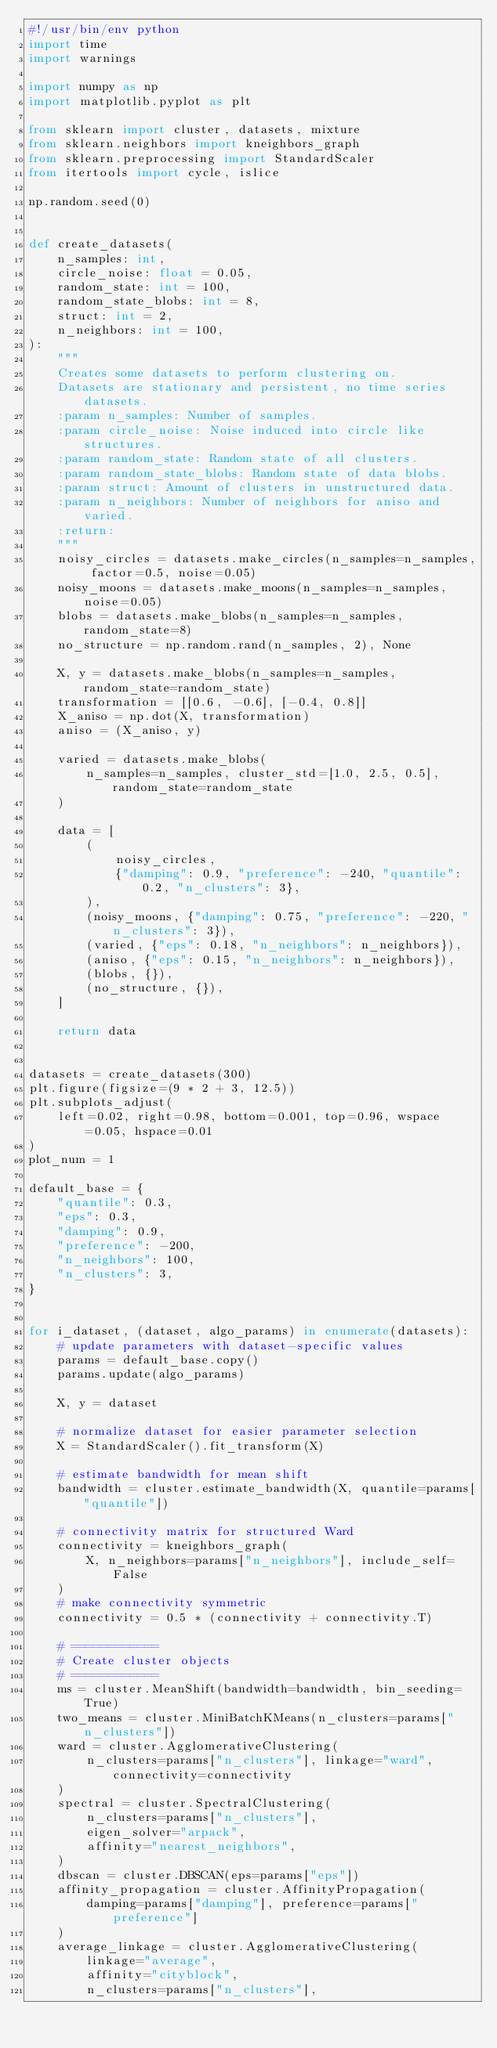Convert code to text. <code><loc_0><loc_0><loc_500><loc_500><_Python_>#!/usr/bin/env python
import time
import warnings

import numpy as np
import matplotlib.pyplot as plt

from sklearn import cluster, datasets, mixture
from sklearn.neighbors import kneighbors_graph
from sklearn.preprocessing import StandardScaler
from itertools import cycle, islice

np.random.seed(0)


def create_datasets(
    n_samples: int,
    circle_noise: float = 0.05,
    random_state: int = 100,
    random_state_blobs: int = 8,
    struct: int = 2,
    n_neighbors: int = 100,
):
    """
    Creates some datasets to perform clustering on.
    Datasets are stationary and persistent, no time series datasets.
    :param n_samples: Number of samples.
    :param circle_noise: Noise induced into circle like structures.
    :param random_state: Random state of all clusters.
    :param random_state_blobs: Random state of data blobs.
    :param struct: Amount of clusters in unstructured data.
    :param n_neighbors: Number of neighbors for aniso and varied.
    :return:
    """
    noisy_circles = datasets.make_circles(n_samples=n_samples, factor=0.5, noise=0.05)
    noisy_moons = datasets.make_moons(n_samples=n_samples, noise=0.05)
    blobs = datasets.make_blobs(n_samples=n_samples, random_state=8)
    no_structure = np.random.rand(n_samples, 2), None

    X, y = datasets.make_blobs(n_samples=n_samples, random_state=random_state)
    transformation = [[0.6, -0.6], [-0.4, 0.8]]
    X_aniso = np.dot(X, transformation)
    aniso = (X_aniso, y)

    varied = datasets.make_blobs(
        n_samples=n_samples, cluster_std=[1.0, 2.5, 0.5], random_state=random_state
    )

    data = [
        (
            noisy_circles,
            {"damping": 0.9, "preference": -240, "quantile": 0.2, "n_clusters": 3},
        ),
        (noisy_moons, {"damping": 0.75, "preference": -220, "n_clusters": 3}),
        (varied, {"eps": 0.18, "n_neighbors": n_neighbors}),
        (aniso, {"eps": 0.15, "n_neighbors": n_neighbors}),
        (blobs, {}),
        (no_structure, {}),
    ]

    return data


datasets = create_datasets(300)
plt.figure(figsize=(9 * 2 + 3, 12.5))
plt.subplots_adjust(
    left=0.02, right=0.98, bottom=0.001, top=0.96, wspace=0.05, hspace=0.01
)
plot_num = 1

default_base = {
    "quantile": 0.3,
    "eps": 0.3,
    "damping": 0.9,
    "preference": -200,
    "n_neighbors": 100,
    "n_clusters": 3,
}


for i_dataset, (dataset, algo_params) in enumerate(datasets):
    # update parameters with dataset-specific values
    params = default_base.copy()
    params.update(algo_params)

    X, y = dataset

    # normalize dataset for easier parameter selection
    X = StandardScaler().fit_transform(X)

    # estimate bandwidth for mean shift
    bandwidth = cluster.estimate_bandwidth(X, quantile=params["quantile"])

    # connectivity matrix for structured Ward
    connectivity = kneighbors_graph(
        X, n_neighbors=params["n_neighbors"], include_self=False
    )
    # make connectivity symmetric
    connectivity = 0.5 * (connectivity + connectivity.T)

    # ============
    # Create cluster objects
    # ============
    ms = cluster.MeanShift(bandwidth=bandwidth, bin_seeding=True)
    two_means = cluster.MiniBatchKMeans(n_clusters=params["n_clusters"])
    ward = cluster.AgglomerativeClustering(
        n_clusters=params["n_clusters"], linkage="ward", connectivity=connectivity
    )
    spectral = cluster.SpectralClustering(
        n_clusters=params["n_clusters"],
        eigen_solver="arpack",
        affinity="nearest_neighbors",
    )
    dbscan = cluster.DBSCAN(eps=params["eps"])
    affinity_propagation = cluster.AffinityPropagation(
        damping=params["damping"], preference=params["preference"]
    )
    average_linkage = cluster.AgglomerativeClustering(
        linkage="average",
        affinity="cityblock",
        n_clusters=params["n_clusters"],</code> 